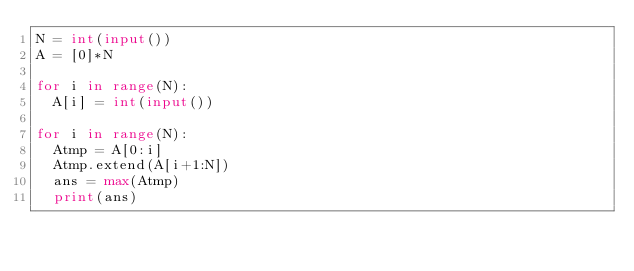Convert code to text. <code><loc_0><loc_0><loc_500><loc_500><_Python_>N = int(input())
A = [0]*N

for i in range(N):
  A[i] = int(input())

for i in range(N):
  Atmp = A[0:i]
  Atmp.extend(A[i+1:N])
  ans = max(Atmp)
  print(ans)
</code> 